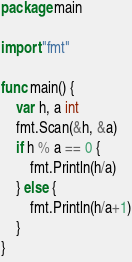Convert code to text. <code><loc_0><loc_0><loc_500><loc_500><_Go_>package main

import "fmt"

func main() {
	var h, a int
	fmt.Scan(&h, &a)
	if h % a == 0 {
		fmt.Println(h/a)
	} else {
		fmt.Println(h/a+1)
	}
}</code> 